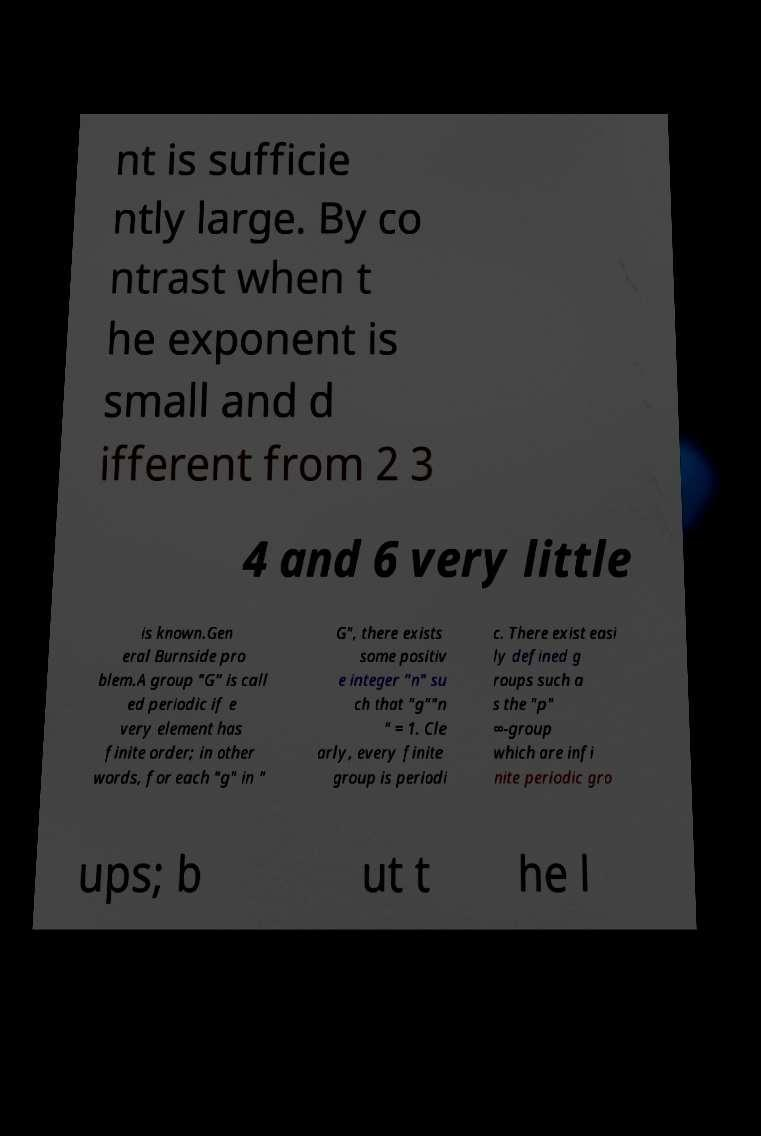Could you assist in decoding the text presented in this image and type it out clearly? nt is sufficie ntly large. By co ntrast when t he exponent is small and d ifferent from 2 3 4 and 6 very little is known.Gen eral Burnside pro blem.A group "G" is call ed periodic if e very element has finite order; in other words, for each "g" in " G", there exists some positiv e integer "n" su ch that "g""n " = 1. Cle arly, every finite group is periodi c. There exist easi ly defined g roups such a s the "p" ∞-group which are infi nite periodic gro ups; b ut t he l 